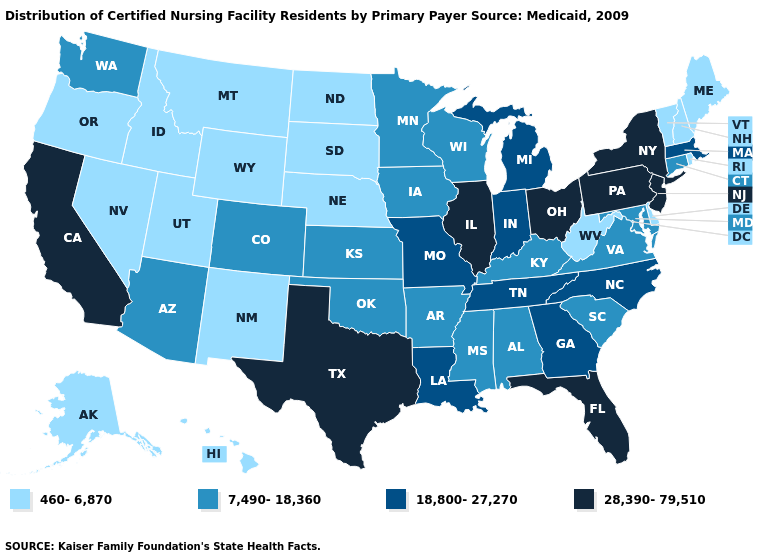Name the states that have a value in the range 460-6,870?
Answer briefly. Alaska, Delaware, Hawaii, Idaho, Maine, Montana, Nebraska, Nevada, New Hampshire, New Mexico, North Dakota, Oregon, Rhode Island, South Dakota, Utah, Vermont, West Virginia, Wyoming. What is the value of Ohio?
Concise answer only. 28,390-79,510. Is the legend a continuous bar?
Short answer required. No. Does Delaware have the lowest value in the South?
Give a very brief answer. Yes. Does Minnesota have the same value as Ohio?
Keep it brief. No. Does New Jersey have the lowest value in the USA?
Be succinct. No. What is the lowest value in states that border Delaware?
Be succinct. 7,490-18,360. Among the states that border Texas , does New Mexico have the lowest value?
Write a very short answer. Yes. Among the states that border North Dakota , which have the highest value?
Keep it brief. Minnesota. Does the first symbol in the legend represent the smallest category?
Answer briefly. Yes. Among the states that border Maryland , does West Virginia have the highest value?
Be succinct. No. How many symbols are there in the legend?
Short answer required. 4. Does Indiana have a lower value than Ohio?
Answer briefly. Yes. Does New York have the lowest value in the Northeast?
Write a very short answer. No. Does the first symbol in the legend represent the smallest category?
Write a very short answer. Yes. 